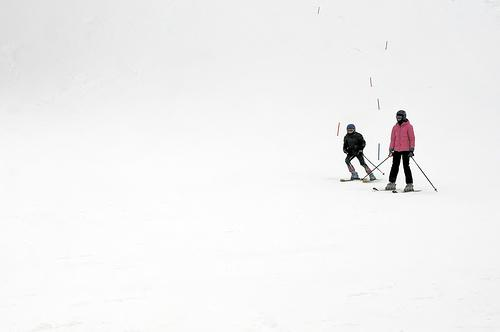Why are sticks stuck into the snow? for skiing 